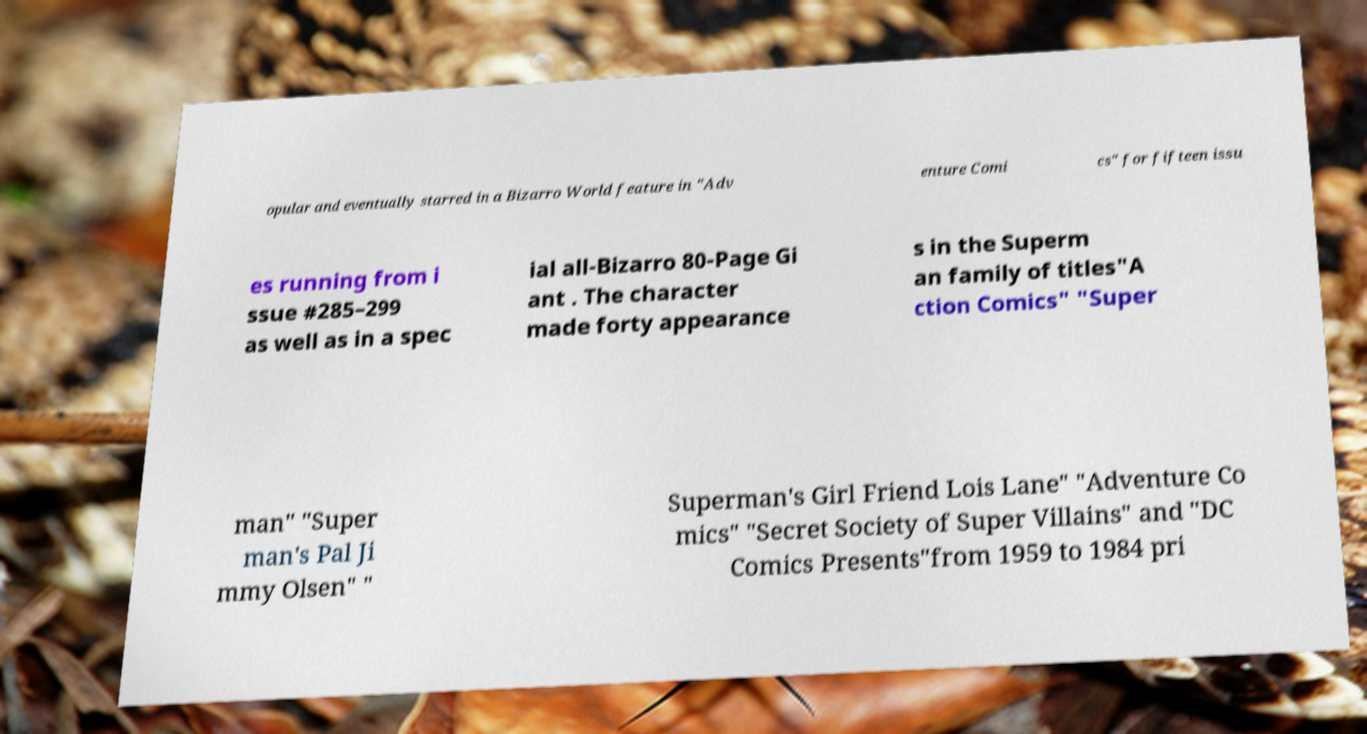Can you accurately transcribe the text from the provided image for me? opular and eventually starred in a Bizarro World feature in "Adv enture Comi cs" for fifteen issu es running from i ssue #285–299 as well as in a spec ial all-Bizarro 80-Page Gi ant . The character made forty appearance s in the Superm an family of titles"A ction Comics" "Super man" "Super man's Pal Ji mmy Olsen" " Superman's Girl Friend Lois Lane" "Adventure Co mics" "Secret Society of Super Villains" and "DC Comics Presents"from 1959 to 1984 pri 